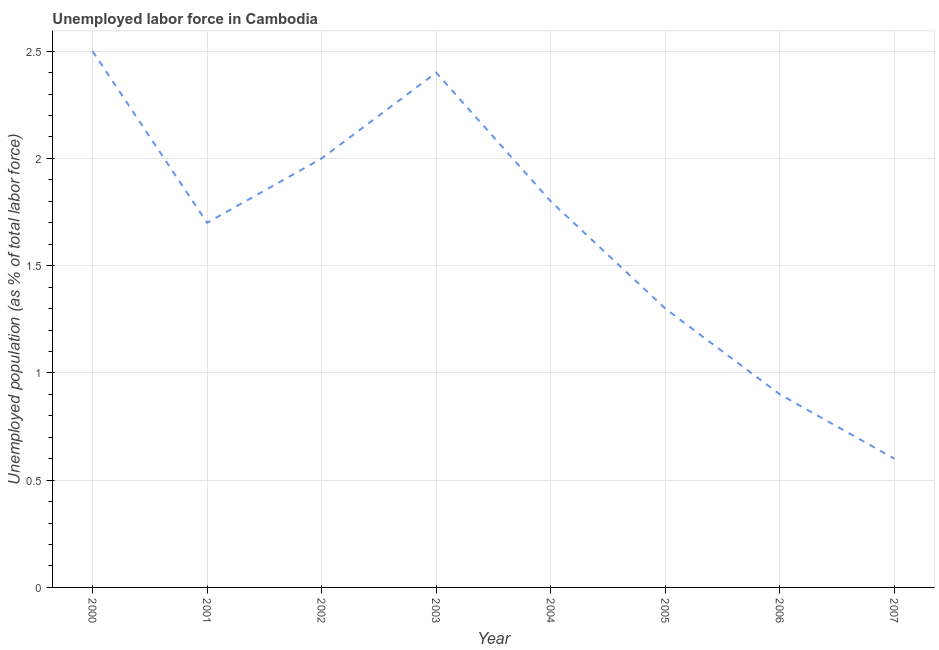What is the total unemployed population in 2004?
Keep it short and to the point. 1.8. Across all years, what is the minimum total unemployed population?
Make the answer very short. 0.6. In which year was the total unemployed population minimum?
Give a very brief answer. 2007. What is the sum of the total unemployed population?
Make the answer very short. 13.2. What is the difference between the total unemployed population in 2005 and 2006?
Give a very brief answer. 0.4. What is the average total unemployed population per year?
Offer a terse response. 1.65. Do a majority of the years between 2004 and 2000 (inclusive) have total unemployed population greater than 1.7 %?
Make the answer very short. Yes. What is the ratio of the total unemployed population in 2000 to that in 2007?
Give a very brief answer. 4.17. Is the total unemployed population in 2001 less than that in 2007?
Provide a short and direct response. No. What is the difference between the highest and the second highest total unemployed population?
Your answer should be very brief. 0.1. Is the sum of the total unemployed population in 2004 and 2005 greater than the maximum total unemployed population across all years?
Offer a terse response. Yes. What is the difference between the highest and the lowest total unemployed population?
Provide a succinct answer. 1.9. In how many years, is the total unemployed population greater than the average total unemployed population taken over all years?
Provide a succinct answer. 5. What is the difference between two consecutive major ticks on the Y-axis?
Your answer should be compact. 0.5. Are the values on the major ticks of Y-axis written in scientific E-notation?
Offer a terse response. No. Does the graph contain grids?
Your response must be concise. Yes. What is the title of the graph?
Make the answer very short. Unemployed labor force in Cambodia. What is the label or title of the X-axis?
Provide a succinct answer. Year. What is the label or title of the Y-axis?
Give a very brief answer. Unemployed population (as % of total labor force). What is the Unemployed population (as % of total labor force) in 2000?
Give a very brief answer. 2.5. What is the Unemployed population (as % of total labor force) in 2001?
Give a very brief answer. 1.7. What is the Unemployed population (as % of total labor force) in 2003?
Offer a very short reply. 2.4. What is the Unemployed population (as % of total labor force) in 2004?
Offer a very short reply. 1.8. What is the Unemployed population (as % of total labor force) in 2005?
Provide a succinct answer. 1.3. What is the Unemployed population (as % of total labor force) of 2006?
Offer a very short reply. 0.9. What is the Unemployed population (as % of total labor force) in 2007?
Keep it short and to the point. 0.6. What is the difference between the Unemployed population (as % of total labor force) in 2000 and 2005?
Make the answer very short. 1.2. What is the difference between the Unemployed population (as % of total labor force) in 2000 and 2007?
Offer a terse response. 1.9. What is the difference between the Unemployed population (as % of total labor force) in 2001 and 2003?
Offer a terse response. -0.7. What is the difference between the Unemployed population (as % of total labor force) in 2001 and 2004?
Offer a very short reply. -0.1. What is the difference between the Unemployed population (as % of total labor force) in 2001 and 2005?
Offer a terse response. 0.4. What is the difference between the Unemployed population (as % of total labor force) in 2001 and 2006?
Ensure brevity in your answer.  0.8. What is the difference between the Unemployed population (as % of total labor force) in 2001 and 2007?
Your answer should be compact. 1.1. What is the difference between the Unemployed population (as % of total labor force) in 2002 and 2006?
Provide a succinct answer. 1.1. What is the difference between the Unemployed population (as % of total labor force) in 2002 and 2007?
Keep it short and to the point. 1.4. What is the difference between the Unemployed population (as % of total labor force) in 2003 and 2004?
Make the answer very short. 0.6. What is the difference between the Unemployed population (as % of total labor force) in 2004 and 2006?
Provide a short and direct response. 0.9. What is the difference between the Unemployed population (as % of total labor force) in 2004 and 2007?
Offer a very short reply. 1.2. What is the difference between the Unemployed population (as % of total labor force) in 2006 and 2007?
Your answer should be very brief. 0.3. What is the ratio of the Unemployed population (as % of total labor force) in 2000 to that in 2001?
Your response must be concise. 1.47. What is the ratio of the Unemployed population (as % of total labor force) in 2000 to that in 2003?
Your answer should be very brief. 1.04. What is the ratio of the Unemployed population (as % of total labor force) in 2000 to that in 2004?
Your response must be concise. 1.39. What is the ratio of the Unemployed population (as % of total labor force) in 2000 to that in 2005?
Offer a very short reply. 1.92. What is the ratio of the Unemployed population (as % of total labor force) in 2000 to that in 2006?
Offer a terse response. 2.78. What is the ratio of the Unemployed population (as % of total labor force) in 2000 to that in 2007?
Your answer should be very brief. 4.17. What is the ratio of the Unemployed population (as % of total labor force) in 2001 to that in 2002?
Make the answer very short. 0.85. What is the ratio of the Unemployed population (as % of total labor force) in 2001 to that in 2003?
Ensure brevity in your answer.  0.71. What is the ratio of the Unemployed population (as % of total labor force) in 2001 to that in 2004?
Make the answer very short. 0.94. What is the ratio of the Unemployed population (as % of total labor force) in 2001 to that in 2005?
Make the answer very short. 1.31. What is the ratio of the Unemployed population (as % of total labor force) in 2001 to that in 2006?
Your answer should be compact. 1.89. What is the ratio of the Unemployed population (as % of total labor force) in 2001 to that in 2007?
Offer a very short reply. 2.83. What is the ratio of the Unemployed population (as % of total labor force) in 2002 to that in 2003?
Ensure brevity in your answer.  0.83. What is the ratio of the Unemployed population (as % of total labor force) in 2002 to that in 2004?
Offer a terse response. 1.11. What is the ratio of the Unemployed population (as % of total labor force) in 2002 to that in 2005?
Give a very brief answer. 1.54. What is the ratio of the Unemployed population (as % of total labor force) in 2002 to that in 2006?
Your answer should be compact. 2.22. What is the ratio of the Unemployed population (as % of total labor force) in 2002 to that in 2007?
Provide a short and direct response. 3.33. What is the ratio of the Unemployed population (as % of total labor force) in 2003 to that in 2004?
Offer a terse response. 1.33. What is the ratio of the Unemployed population (as % of total labor force) in 2003 to that in 2005?
Ensure brevity in your answer.  1.85. What is the ratio of the Unemployed population (as % of total labor force) in 2003 to that in 2006?
Provide a succinct answer. 2.67. What is the ratio of the Unemployed population (as % of total labor force) in 2003 to that in 2007?
Keep it short and to the point. 4. What is the ratio of the Unemployed population (as % of total labor force) in 2004 to that in 2005?
Make the answer very short. 1.39. What is the ratio of the Unemployed population (as % of total labor force) in 2004 to that in 2007?
Provide a short and direct response. 3. What is the ratio of the Unemployed population (as % of total labor force) in 2005 to that in 2006?
Provide a short and direct response. 1.44. What is the ratio of the Unemployed population (as % of total labor force) in 2005 to that in 2007?
Make the answer very short. 2.17. 